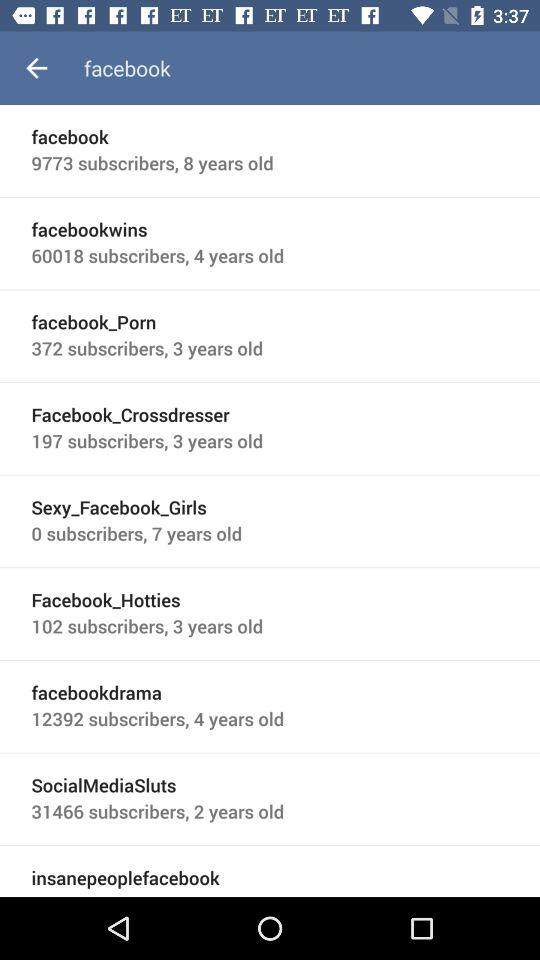How old is "facebookwins"? "facebookwins" is 4 years old. 